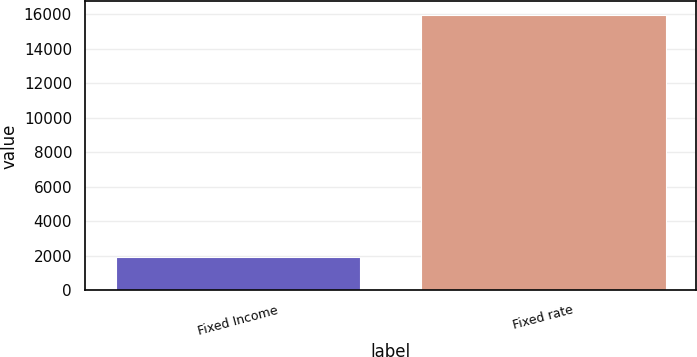Convert chart to OTSL. <chart><loc_0><loc_0><loc_500><loc_500><bar_chart><fcel>Fixed Income<fcel>Fixed rate<nl><fcel>1915<fcel>15948<nl></chart> 